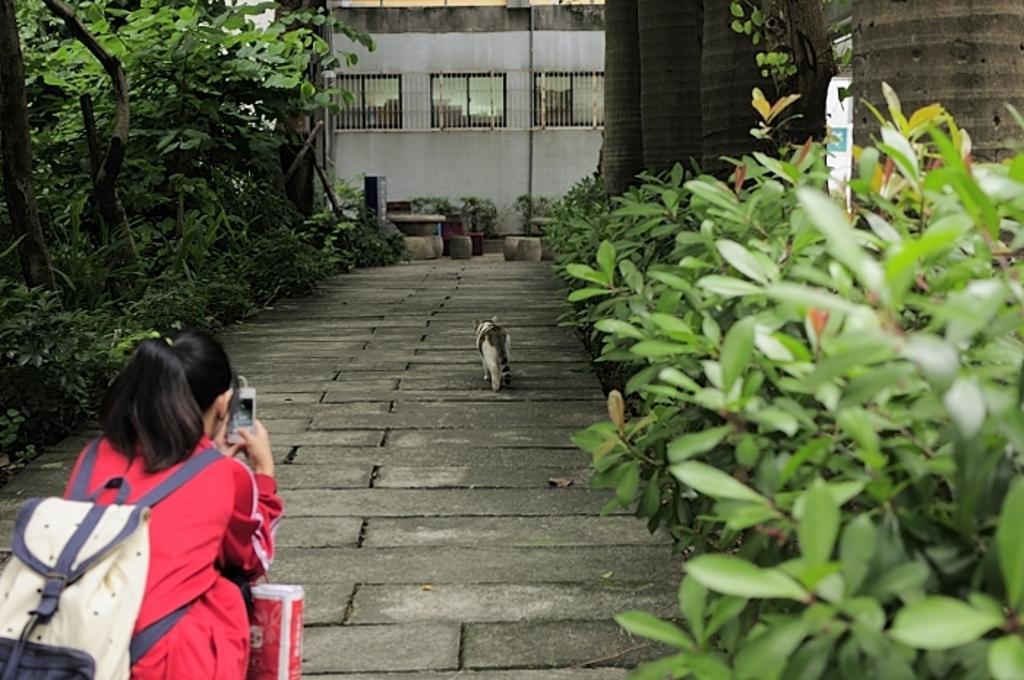How would you summarize this image in a sentence or two? In this image we can see a cat moving on the path of a road, behind the cat there is a girl wearing a red dress and a bag,holding a phone. On the either sides of the road there are trees and plants. In the background there is a building, in front of the building there are some objects placed on the path. 